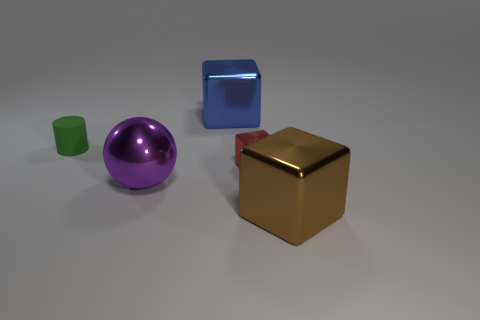Add 4 purple metal spheres. How many objects exist? 9 Subtract all cylinders. How many objects are left? 4 Add 2 shiny cubes. How many shiny cubes are left? 5 Add 1 matte objects. How many matte objects exist? 2 Subtract 0 gray blocks. How many objects are left? 5 Subtract all rubber blocks. Subtract all green cylinders. How many objects are left? 4 